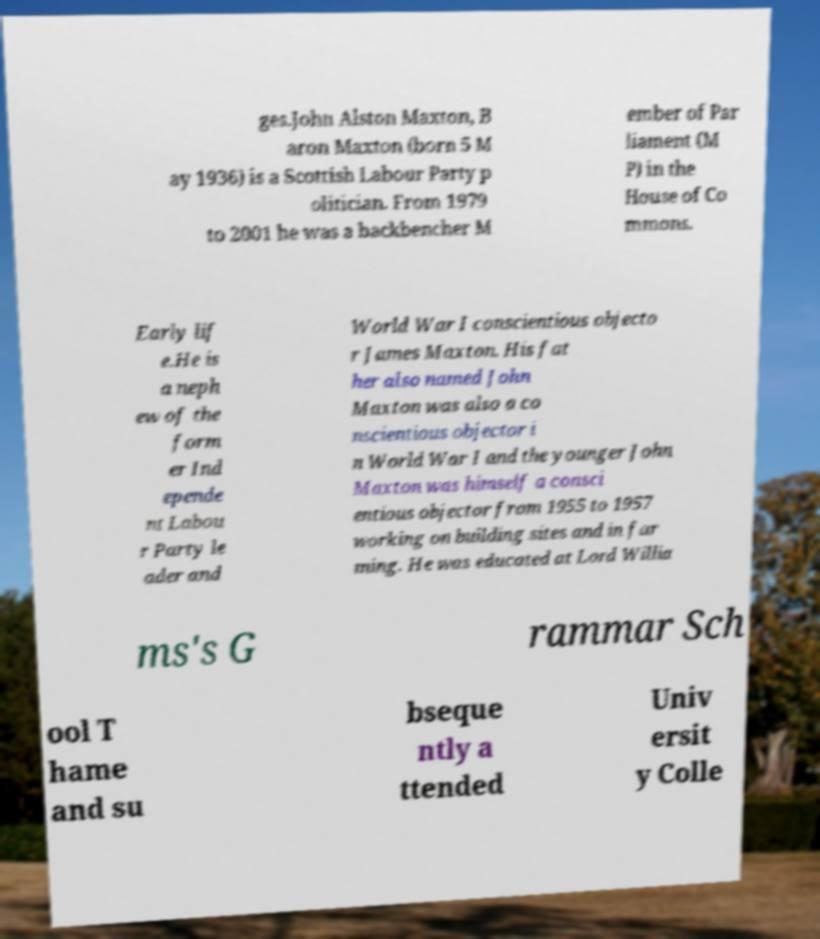Could you extract and type out the text from this image? ges.John Alston Maxton, B aron Maxton (born 5 M ay 1936) is a Scottish Labour Party p olitician. From 1979 to 2001 he was a backbencher M ember of Par liament (M P) in the House of Co mmons. Early lif e.He is a neph ew of the form er Ind epende nt Labou r Party le ader and World War I conscientious objecto r James Maxton. His fat her also named John Maxton was also a co nscientious objector i n World War I and the younger John Maxton was himself a consci entious objector from 1955 to 1957 working on building sites and in far ming. He was educated at Lord Willia ms's G rammar Sch ool T hame and su bseque ntly a ttended Univ ersit y Colle 